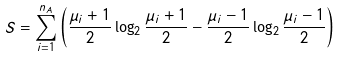Convert formula to latex. <formula><loc_0><loc_0><loc_500><loc_500>S = \sum _ { i = 1 } ^ { n _ { A } } \left ( \frac { \mu _ { i } + 1 } { 2 } \log _ { 2 } \frac { \mu _ { i } + 1 } { 2 } - \frac { \mu _ { i } - 1 } { 2 } \log _ { 2 } \frac { \mu _ { i } - 1 } { 2 } \right )</formula> 